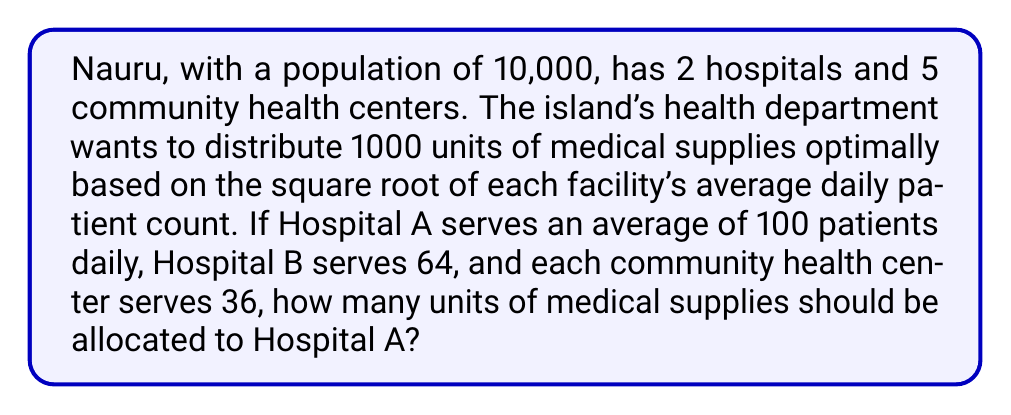What is the answer to this math problem? Let's approach this step-by-step:

1) First, we need to calculate the square root of each facility's average daily patient count:

   Hospital A: $\sqrt{100} = 10$
   Hospital B: $\sqrt{64} = 8$
   Each community health center: $\sqrt{36} = 6$

2) Now, we need to sum up these square roots:

   Total = $10 + 8 + (5 \times 6) = 18 + 30 = 48$

3) The proportion of supplies for Hospital A will be its square root divided by the total:

   $\frac{10}{48}$

4) To find the number of units, we multiply this fraction by the total number of supplies:

   $\frac{10}{48} \times 1000 = \frac{10000}{48} = 208.33...$

5) Since we can't allocate partial units, we round to the nearest whole number:

   $208.33... \approx 208$ units
Answer: 208 units 